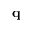Convert formula to latex. <formula><loc_0><loc_0><loc_500><loc_500>q</formula> 